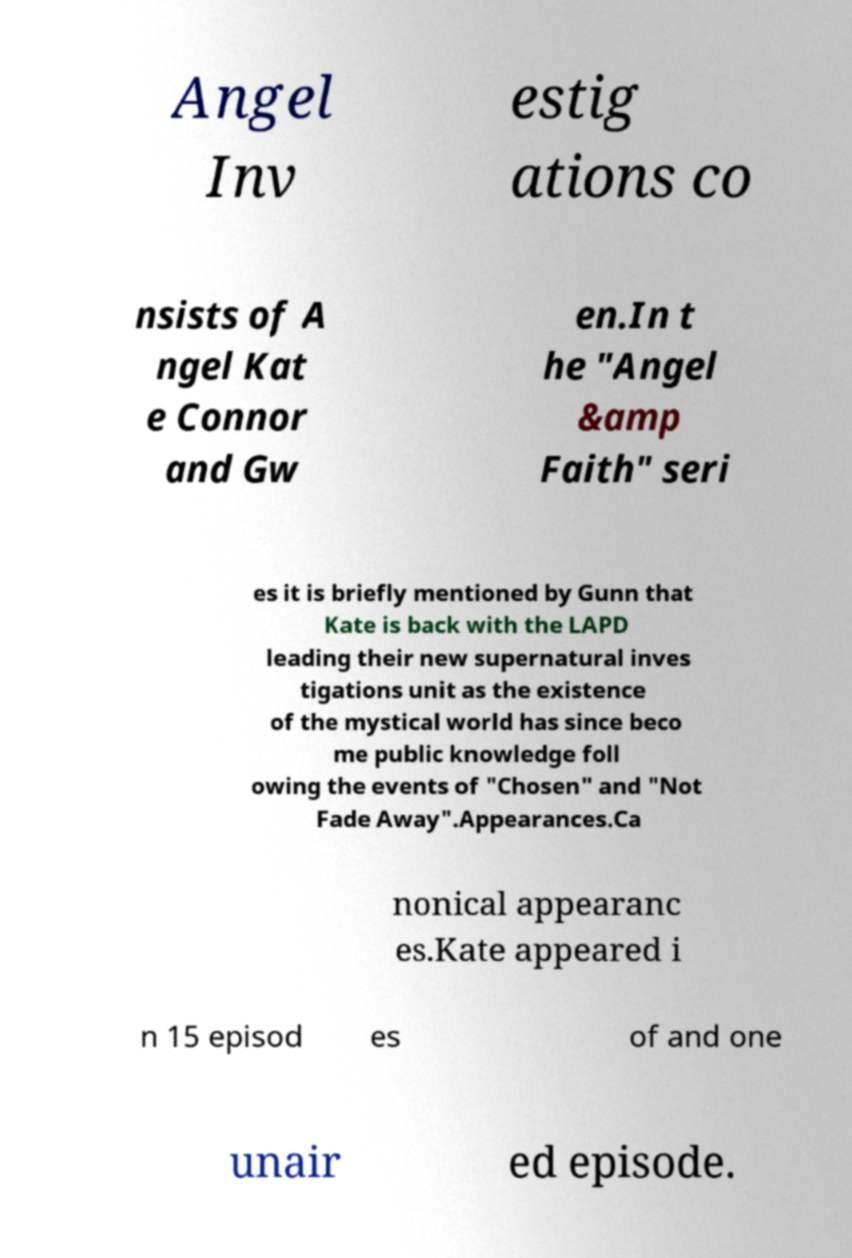For documentation purposes, I need the text within this image transcribed. Could you provide that? Angel Inv estig ations co nsists of A ngel Kat e Connor and Gw en.In t he "Angel &amp Faith" seri es it is briefly mentioned by Gunn that Kate is back with the LAPD leading their new supernatural inves tigations unit as the existence of the mystical world has since beco me public knowledge foll owing the events of "Chosen" and "Not Fade Away".Appearances.Ca nonical appearanc es.Kate appeared i n 15 episod es of and one unair ed episode. 